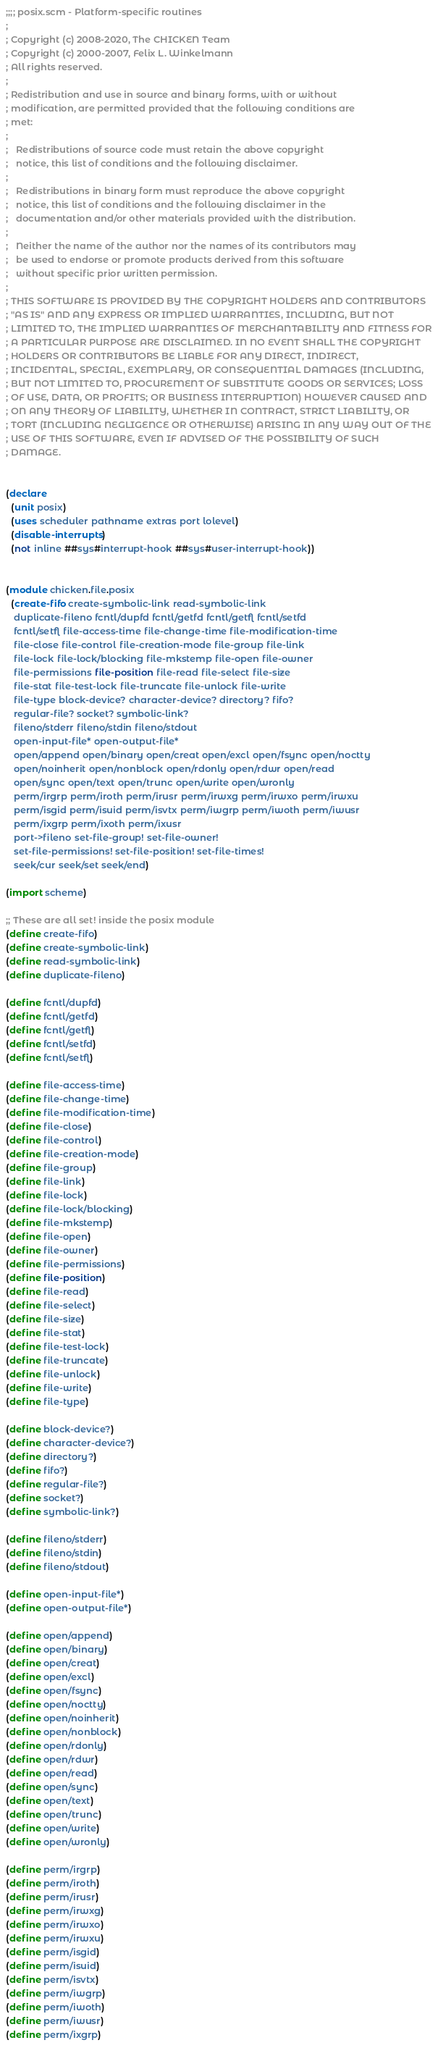Convert code to text. <code><loc_0><loc_0><loc_500><loc_500><_Scheme_>;;;; posix.scm - Platform-specific routines
;
; Copyright (c) 2008-2020, The CHICKEN Team
; Copyright (c) 2000-2007, Felix L. Winkelmann
; All rights reserved.
;
; Redistribution and use in source and binary forms, with or without
; modification, are permitted provided that the following conditions are
; met:
;
;   Redistributions of source code must retain the above copyright
;   notice, this list of conditions and the following disclaimer.
;
;   Redistributions in binary form must reproduce the above copyright
;   notice, this list of conditions and the following disclaimer in the
;   documentation and/or other materials provided with the distribution.
;
;   Neither the name of the author nor the names of its contributors may
;   be used to endorse or promote products derived from this software
;   without specific prior written permission.
;
; THIS SOFTWARE IS PROVIDED BY THE COPYRIGHT HOLDERS AND CONTRIBUTORS
; "AS IS" AND ANY EXPRESS OR IMPLIED WARRANTIES, INCLUDING, BUT NOT
; LIMITED TO, THE IMPLIED WARRANTIES OF MERCHANTABILITY AND FITNESS FOR
; A PARTICULAR PURPOSE ARE DISCLAIMED. IN NO EVENT SHALL THE COPYRIGHT
; HOLDERS OR CONTRIBUTORS BE LIABLE FOR ANY DIRECT, INDIRECT,
; INCIDENTAL, SPECIAL, EXEMPLARY, OR CONSEQUENTIAL DAMAGES (INCLUDING,
; BUT NOT LIMITED TO, PROCUREMENT OF SUBSTITUTE GOODS OR SERVICES; LOSS
; OF USE, DATA, OR PROFITS; OR BUSINESS INTERRUPTION) HOWEVER CAUSED AND
; ON ANY THEORY OF LIABILITY, WHETHER IN CONTRACT, STRICT LIABILITY, OR
; TORT (INCLUDING NEGLIGENCE OR OTHERWISE) ARISING IN ANY WAY OUT OF THE
; USE OF THIS SOFTWARE, EVEN IF ADVISED OF THE POSSIBILITY OF SUCH
; DAMAGE.


(declare
  (unit posix)
  (uses scheduler pathname extras port lolevel)
  (disable-interrupts)
  (not inline ##sys#interrupt-hook ##sys#user-interrupt-hook))


(module chicken.file.posix
  (create-fifo create-symbolic-link read-symbolic-link
   duplicate-fileno fcntl/dupfd fcntl/getfd fcntl/getfl fcntl/setfd
   fcntl/setfl file-access-time file-change-time file-modification-time
   file-close file-control file-creation-mode file-group file-link
   file-lock file-lock/blocking file-mkstemp file-open file-owner
   file-permissions file-position file-read file-select file-size
   file-stat file-test-lock file-truncate file-unlock file-write
   file-type block-device? character-device? directory? fifo?
   regular-file? socket? symbolic-link?
   fileno/stderr fileno/stdin fileno/stdout
   open-input-file* open-output-file*
   open/append open/binary open/creat open/excl open/fsync open/noctty
   open/noinherit open/nonblock open/rdonly open/rdwr open/read
   open/sync open/text open/trunc open/write open/wronly
   perm/irgrp perm/iroth perm/irusr perm/irwxg perm/irwxo perm/irwxu
   perm/isgid perm/isuid perm/isvtx perm/iwgrp perm/iwoth perm/iwusr
   perm/ixgrp perm/ixoth perm/ixusr
   port->fileno set-file-group! set-file-owner!
   set-file-permissions! set-file-position! set-file-times!
   seek/cur seek/set seek/end)

(import scheme)

;; These are all set! inside the posix module
(define create-fifo)
(define create-symbolic-link)
(define read-symbolic-link)
(define duplicate-fileno)

(define fcntl/dupfd)
(define fcntl/getfd)
(define fcntl/getfl)
(define fcntl/setfd)
(define fcntl/setfl)

(define file-access-time)
(define file-change-time)
(define file-modification-time)
(define file-close)
(define file-control)
(define file-creation-mode)
(define file-group)
(define file-link)
(define file-lock)
(define file-lock/blocking)
(define file-mkstemp)
(define file-open)
(define file-owner)
(define file-permissions)
(define file-position)
(define file-read)
(define file-select)
(define file-size)
(define file-stat)
(define file-test-lock)
(define file-truncate)
(define file-unlock)
(define file-write)
(define file-type)

(define block-device?)
(define character-device?)
(define directory?)
(define fifo?)
(define regular-file?)
(define socket?)
(define symbolic-link?)
  
(define fileno/stderr)
(define fileno/stdin)
(define fileno/stdout)
  
(define open-input-file*)
(define open-output-file*)
  
(define open/append)
(define open/binary)
(define open/creat)
(define open/excl)
(define open/fsync)
(define open/noctty)
(define open/noinherit)
(define open/nonblock)
(define open/rdonly)
(define open/rdwr)
(define open/read)
(define open/sync)
(define open/text)
(define open/trunc)
(define open/write)
(define open/wronly)
  
(define perm/irgrp)
(define perm/iroth)
(define perm/irusr)
(define perm/irwxg)
(define perm/irwxo)
(define perm/irwxu)
(define perm/isgid)
(define perm/isuid)
(define perm/isvtx)
(define perm/iwgrp)
(define perm/iwoth)
(define perm/iwusr)
(define perm/ixgrp)</code> 